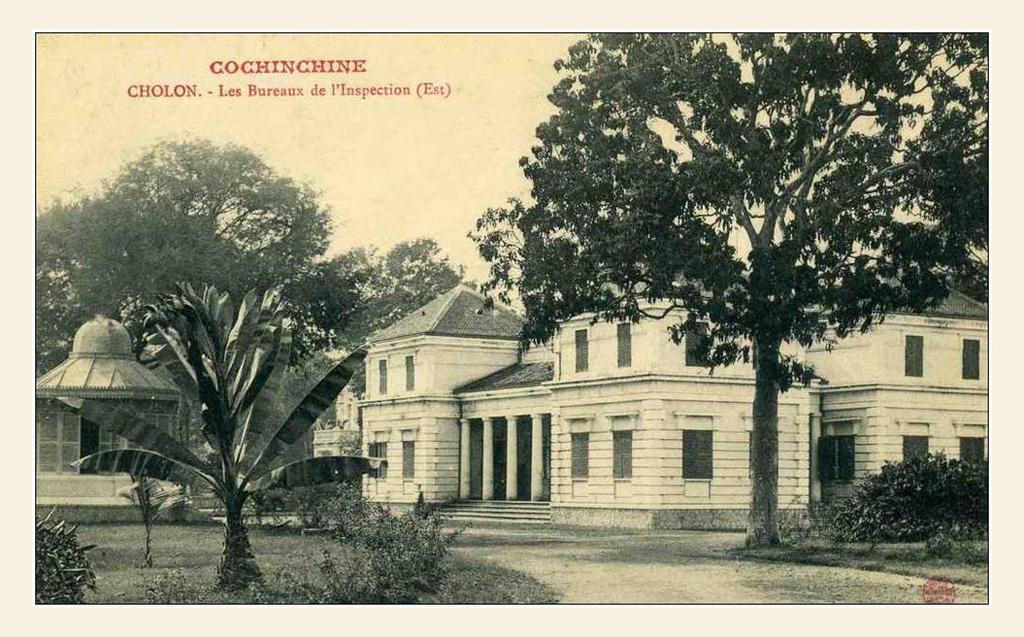What type of vegetation can be seen in the image? There are trees, plants, and grass in the image. What kind of surface is visible in the image? There is a path in the image. What structures can be seen in the image? There are buildings in the image. What else is visible in the image besides the vegetation and structures? There is text and the sky visible in the image. How old does the image appear to be? The image appears to be old. How many chickens are visible in the image? There are no chickens present in the image. What type of sound can be heard coming from the trees in the image? There is no sound present in the image, as it is a still photograph. 